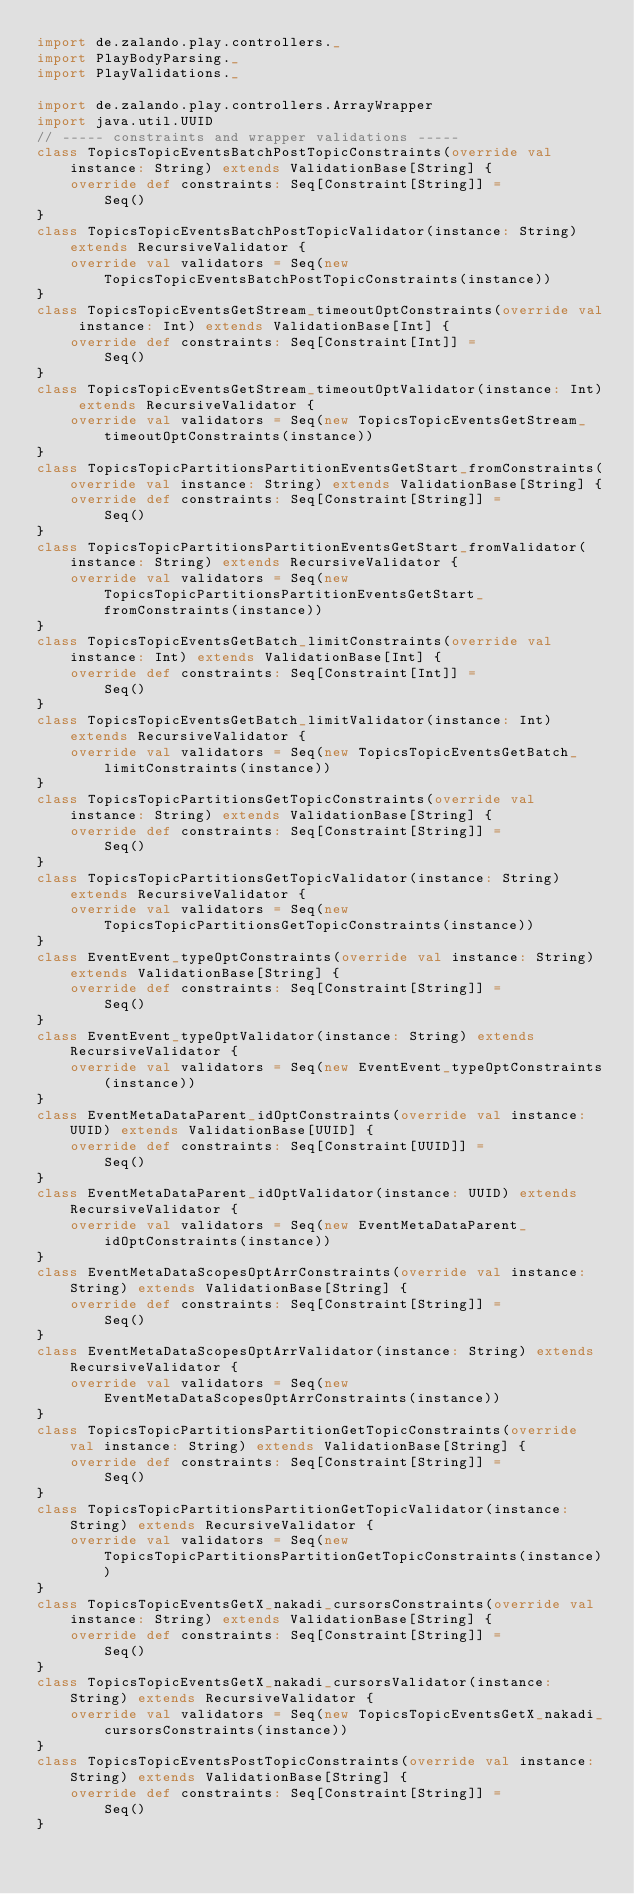Convert code to text. <code><loc_0><loc_0><loc_500><loc_500><_Scala_>import de.zalando.play.controllers._
import PlayBodyParsing._
import PlayValidations._

import de.zalando.play.controllers.ArrayWrapper
import java.util.UUID
// ----- constraints and wrapper validations -----
class TopicsTopicEventsBatchPostTopicConstraints(override val instance: String) extends ValidationBase[String] {
    override def constraints: Seq[Constraint[String]] =
        Seq()
}
class TopicsTopicEventsBatchPostTopicValidator(instance: String) extends RecursiveValidator {
    override val validators = Seq(new TopicsTopicEventsBatchPostTopicConstraints(instance))
}
class TopicsTopicEventsGetStream_timeoutOptConstraints(override val instance: Int) extends ValidationBase[Int] {
    override def constraints: Seq[Constraint[Int]] =
        Seq()
}
class TopicsTopicEventsGetStream_timeoutOptValidator(instance: Int) extends RecursiveValidator {
    override val validators = Seq(new TopicsTopicEventsGetStream_timeoutOptConstraints(instance))
}
class TopicsTopicPartitionsPartitionEventsGetStart_fromConstraints(override val instance: String) extends ValidationBase[String] {
    override def constraints: Seq[Constraint[String]] =
        Seq()
}
class TopicsTopicPartitionsPartitionEventsGetStart_fromValidator(instance: String) extends RecursiveValidator {
    override val validators = Seq(new TopicsTopicPartitionsPartitionEventsGetStart_fromConstraints(instance))
}
class TopicsTopicEventsGetBatch_limitConstraints(override val instance: Int) extends ValidationBase[Int] {
    override def constraints: Seq[Constraint[Int]] =
        Seq()
}
class TopicsTopicEventsGetBatch_limitValidator(instance: Int) extends RecursiveValidator {
    override val validators = Seq(new TopicsTopicEventsGetBatch_limitConstraints(instance))
}
class TopicsTopicPartitionsGetTopicConstraints(override val instance: String) extends ValidationBase[String] {
    override def constraints: Seq[Constraint[String]] =
        Seq()
}
class TopicsTopicPartitionsGetTopicValidator(instance: String) extends RecursiveValidator {
    override val validators = Seq(new TopicsTopicPartitionsGetTopicConstraints(instance))
}
class EventEvent_typeOptConstraints(override val instance: String) extends ValidationBase[String] {
    override def constraints: Seq[Constraint[String]] =
        Seq()
}
class EventEvent_typeOptValidator(instance: String) extends RecursiveValidator {
    override val validators = Seq(new EventEvent_typeOptConstraints(instance))
}
class EventMetaDataParent_idOptConstraints(override val instance: UUID) extends ValidationBase[UUID] {
    override def constraints: Seq[Constraint[UUID]] =
        Seq()
}
class EventMetaDataParent_idOptValidator(instance: UUID) extends RecursiveValidator {
    override val validators = Seq(new EventMetaDataParent_idOptConstraints(instance))
}
class EventMetaDataScopesOptArrConstraints(override val instance: String) extends ValidationBase[String] {
    override def constraints: Seq[Constraint[String]] =
        Seq()
}
class EventMetaDataScopesOptArrValidator(instance: String) extends RecursiveValidator {
    override val validators = Seq(new EventMetaDataScopesOptArrConstraints(instance))
}
class TopicsTopicPartitionsPartitionGetTopicConstraints(override val instance: String) extends ValidationBase[String] {
    override def constraints: Seq[Constraint[String]] =
        Seq()
}
class TopicsTopicPartitionsPartitionGetTopicValidator(instance: String) extends RecursiveValidator {
    override val validators = Seq(new TopicsTopicPartitionsPartitionGetTopicConstraints(instance))
}
class TopicsTopicEventsGetX_nakadi_cursorsConstraints(override val instance: String) extends ValidationBase[String] {
    override def constraints: Seq[Constraint[String]] =
        Seq()
}
class TopicsTopicEventsGetX_nakadi_cursorsValidator(instance: String) extends RecursiveValidator {
    override val validators = Seq(new TopicsTopicEventsGetX_nakadi_cursorsConstraints(instance))
}
class TopicsTopicEventsPostTopicConstraints(override val instance: String) extends ValidationBase[String] {
    override def constraints: Seq[Constraint[String]] =
        Seq()
}</code> 